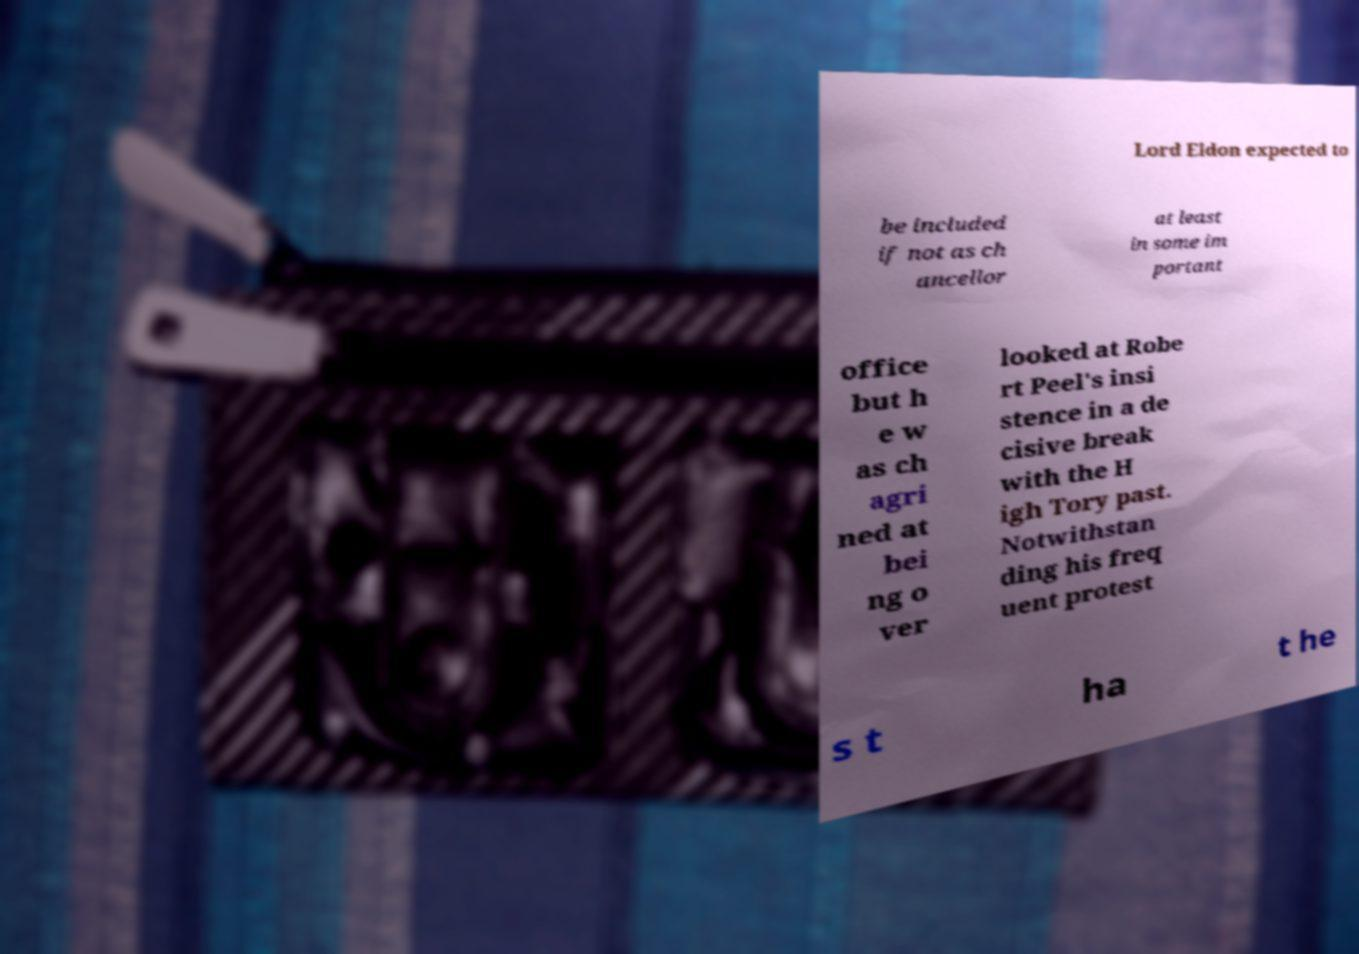I need the written content from this picture converted into text. Can you do that? Lord Eldon expected to be included if not as ch ancellor at least in some im portant office but h e w as ch agri ned at bei ng o ver looked at Robe rt Peel's insi stence in a de cisive break with the H igh Tory past. Notwithstan ding his freq uent protest s t ha t he 